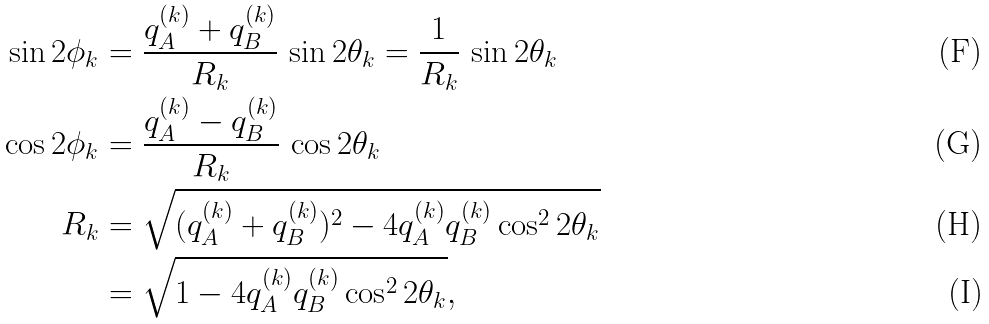<formula> <loc_0><loc_0><loc_500><loc_500>\sin 2 \phi _ { k } & = \frac { q ^ { ( k ) } _ { A } + q ^ { ( k ) } _ { B } } { R _ { k } } \, \sin 2 \theta _ { k } = \frac { 1 } { R _ { k } } \, \sin 2 \theta _ { k } \\ \cos 2 \phi _ { k } & = \frac { q ^ { ( k ) } _ { A } - q ^ { ( k ) } _ { B } } { R _ { k } } \, \cos 2 \theta _ { k } \\ R _ { k } & = \sqrt { ( q ^ { ( k ) } _ { A } + q ^ { ( k ) } _ { B } ) ^ { 2 } - 4 q ^ { ( k ) } _ { A } q ^ { ( k ) } _ { B } \cos ^ { 2 } 2 \theta _ { k } } \\ & = \sqrt { 1 - 4 q ^ { ( k ) } _ { A } q ^ { ( k ) } _ { B } \cos ^ { 2 } 2 \theta _ { k } } ,</formula> 